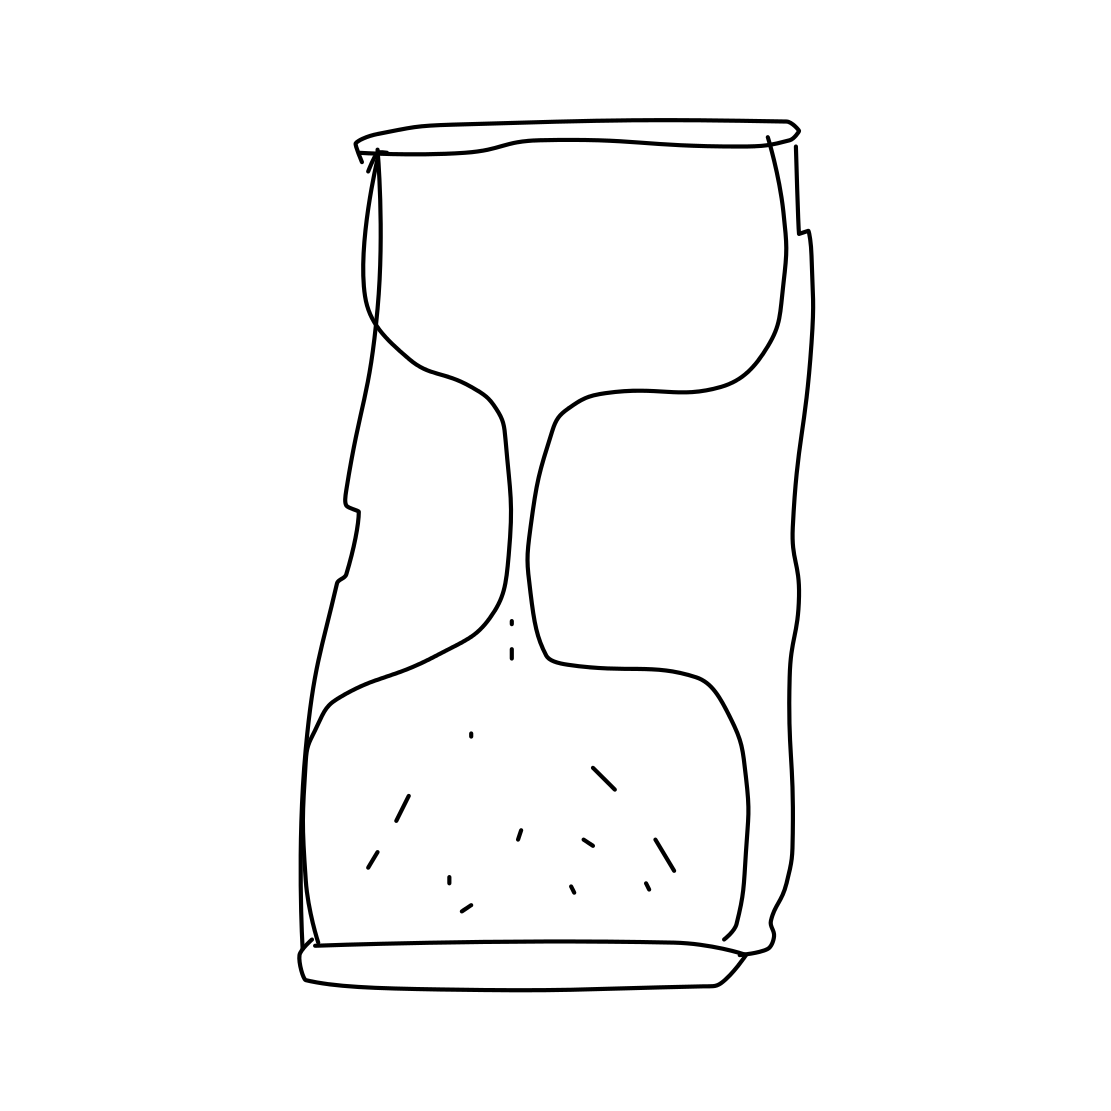Describe the artistic style of the drawing. The artistic style of the drawing is minimalist and abstract. It features clean lines, sparse detail, and an open composition, leaving much to interpretation. The simplicity of the design focuses on the essence of form rather than the intricacies of realistic depiction. How might this type of art be used or interpreted? This style of art can be used to evoke emotion or convey a concept with minimal visual elements. Its ambiguity allows viewers to project their own meanings or stories onto the piece, making it dynamic and interactive in a way. It's often appreciated for its aesthetic purity and thought-provoking simplicity. 